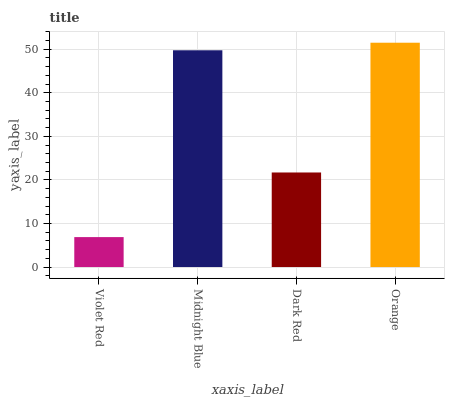Is Violet Red the minimum?
Answer yes or no. Yes. Is Orange the maximum?
Answer yes or no. Yes. Is Midnight Blue the minimum?
Answer yes or no. No. Is Midnight Blue the maximum?
Answer yes or no. No. Is Midnight Blue greater than Violet Red?
Answer yes or no. Yes. Is Violet Red less than Midnight Blue?
Answer yes or no. Yes. Is Violet Red greater than Midnight Blue?
Answer yes or no. No. Is Midnight Blue less than Violet Red?
Answer yes or no. No. Is Midnight Blue the high median?
Answer yes or no. Yes. Is Dark Red the low median?
Answer yes or no. Yes. Is Dark Red the high median?
Answer yes or no. No. Is Orange the low median?
Answer yes or no. No. 